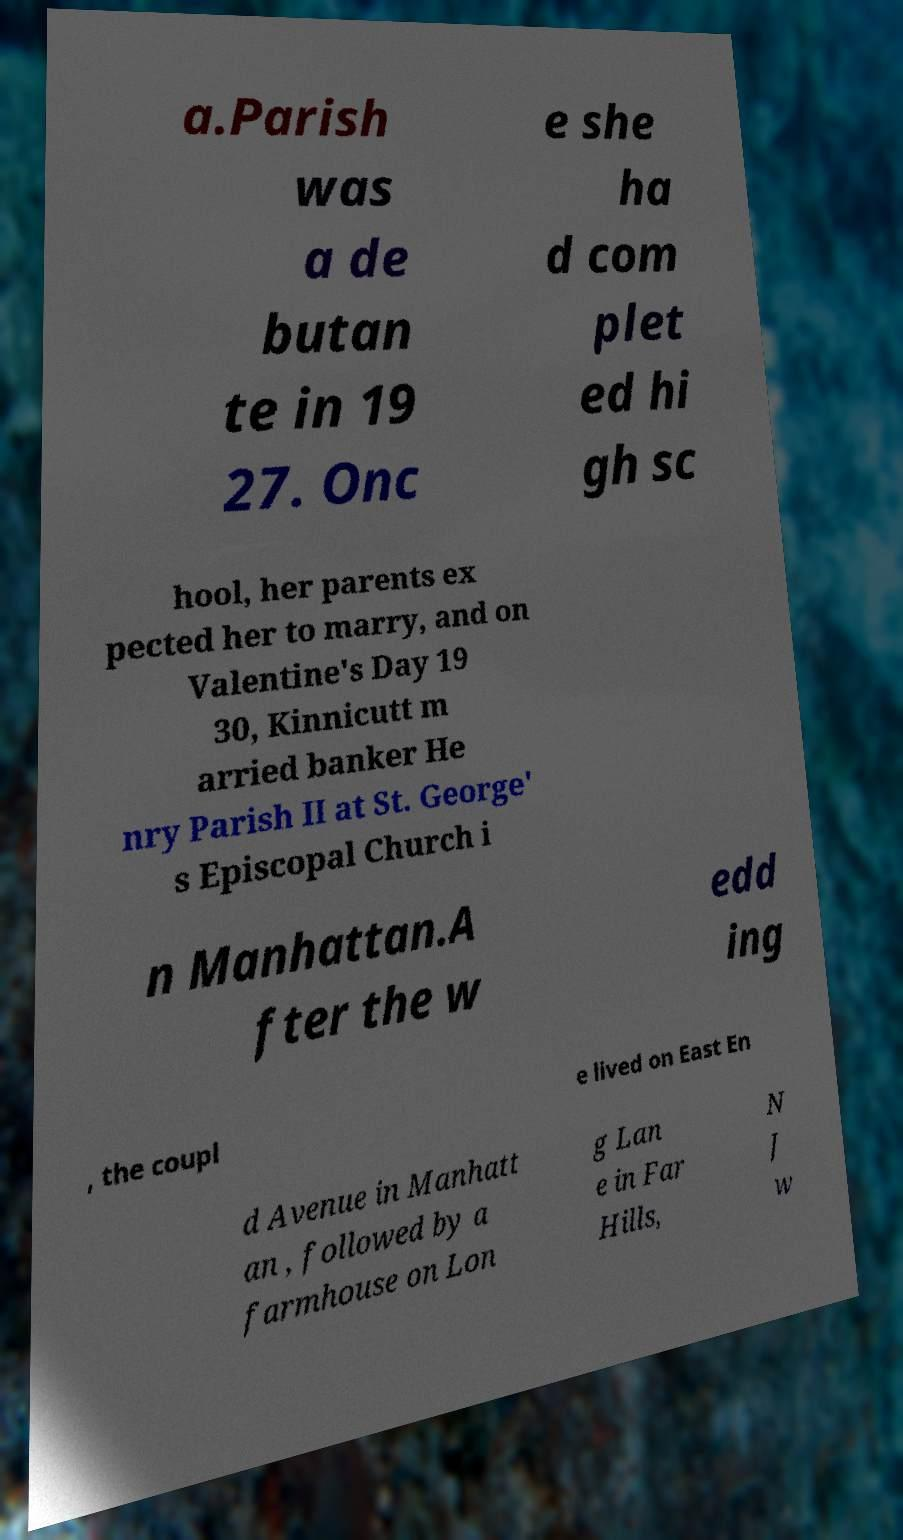Please identify and transcribe the text found in this image. a.Parish was a de butan te in 19 27. Onc e she ha d com plet ed hi gh sc hool, her parents ex pected her to marry, and on Valentine's Day 19 30, Kinnicutt m arried banker He nry Parish II at St. George' s Episcopal Church i n Manhattan.A fter the w edd ing , the coupl e lived on East En d Avenue in Manhatt an , followed by a farmhouse on Lon g Lan e in Far Hills, N J w 